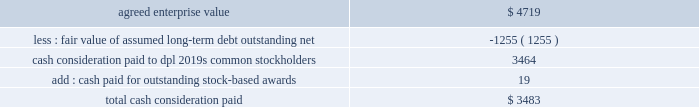The aes corporation notes to consolidated financial statements 2014 ( continued ) december 31 , 2011 , 2010 , and 2009 company for an aggregate proceeds of approximately $ 234 million .
The company recognized a gain on disposal of $ 6 million , net of tax , during the year ended december 31 , 2010 .
Ras laffan was previously reported in the asia generation segment .
23 .
Acquisitions and dispositions acquisitions dpl 2014on november 28 , 2011 , aes completed its acquisition of 100% ( 100 % ) of the common stock of dpl for approximately $ 3.5 billion , pursuant to the terms and conditions of a definitive agreement ( the 201cmerger agreement 201d ) dated april 19 , 2011 .
Dpl serves over 500000 customers , primarily west central ohio , through its operating subsidiaries dp&l and dpl energy resources ( 201cdpler 201d ) .
Additionally , dpl operates over 3800 mw of power generation facilities and provides competitive retail energy services to residential , commercial , industrial and governmental customers .
The acquisition strengthens the company 2019s u.s .
Utility operations by expanding in the midwest and pjm , a regional transmission organization serving several eastern states as part of the eastern interconnection .
The company expects to benefit from the regional scale provided by indianapolis power & light company , its nearby integrated utility business in indiana .
Aes funded the aggregate purchase consideration through a combination of the following : 2022 the proceeds from a $ 1.05 billion term loan obtained in may 2011 ; 2022 the proceeds from a private offering of $ 1.0 billion notes in june 2011 ; 2022 temporary borrowings of $ 251 million under its revolving credit facility ; and 2022 the proceeds from private offerings of $ 450 million aggregate principal amount of 6.50% ( 6.50 % ) senior notes due 2016 and $ 800 million aggregate principal amount of 7.25% ( 7.25 % ) senior notes due 2021 ( collectively , the 201cnotes 201d ) in october 2011 by dolphin subsidiary ii , inc .
( 201cdolphin ii 201d ) , a wholly-owned special purpose indirect subsidiary of aes , which was merged into dpl upon the completion of acquisition .
The fair value of the consideration paid for dpl was as follows ( in millions ) : .

Total cash consideration was what percent of the enterprise value of dpl? 
Computations: (3483 / 4719)
Answer: 0.73808. 